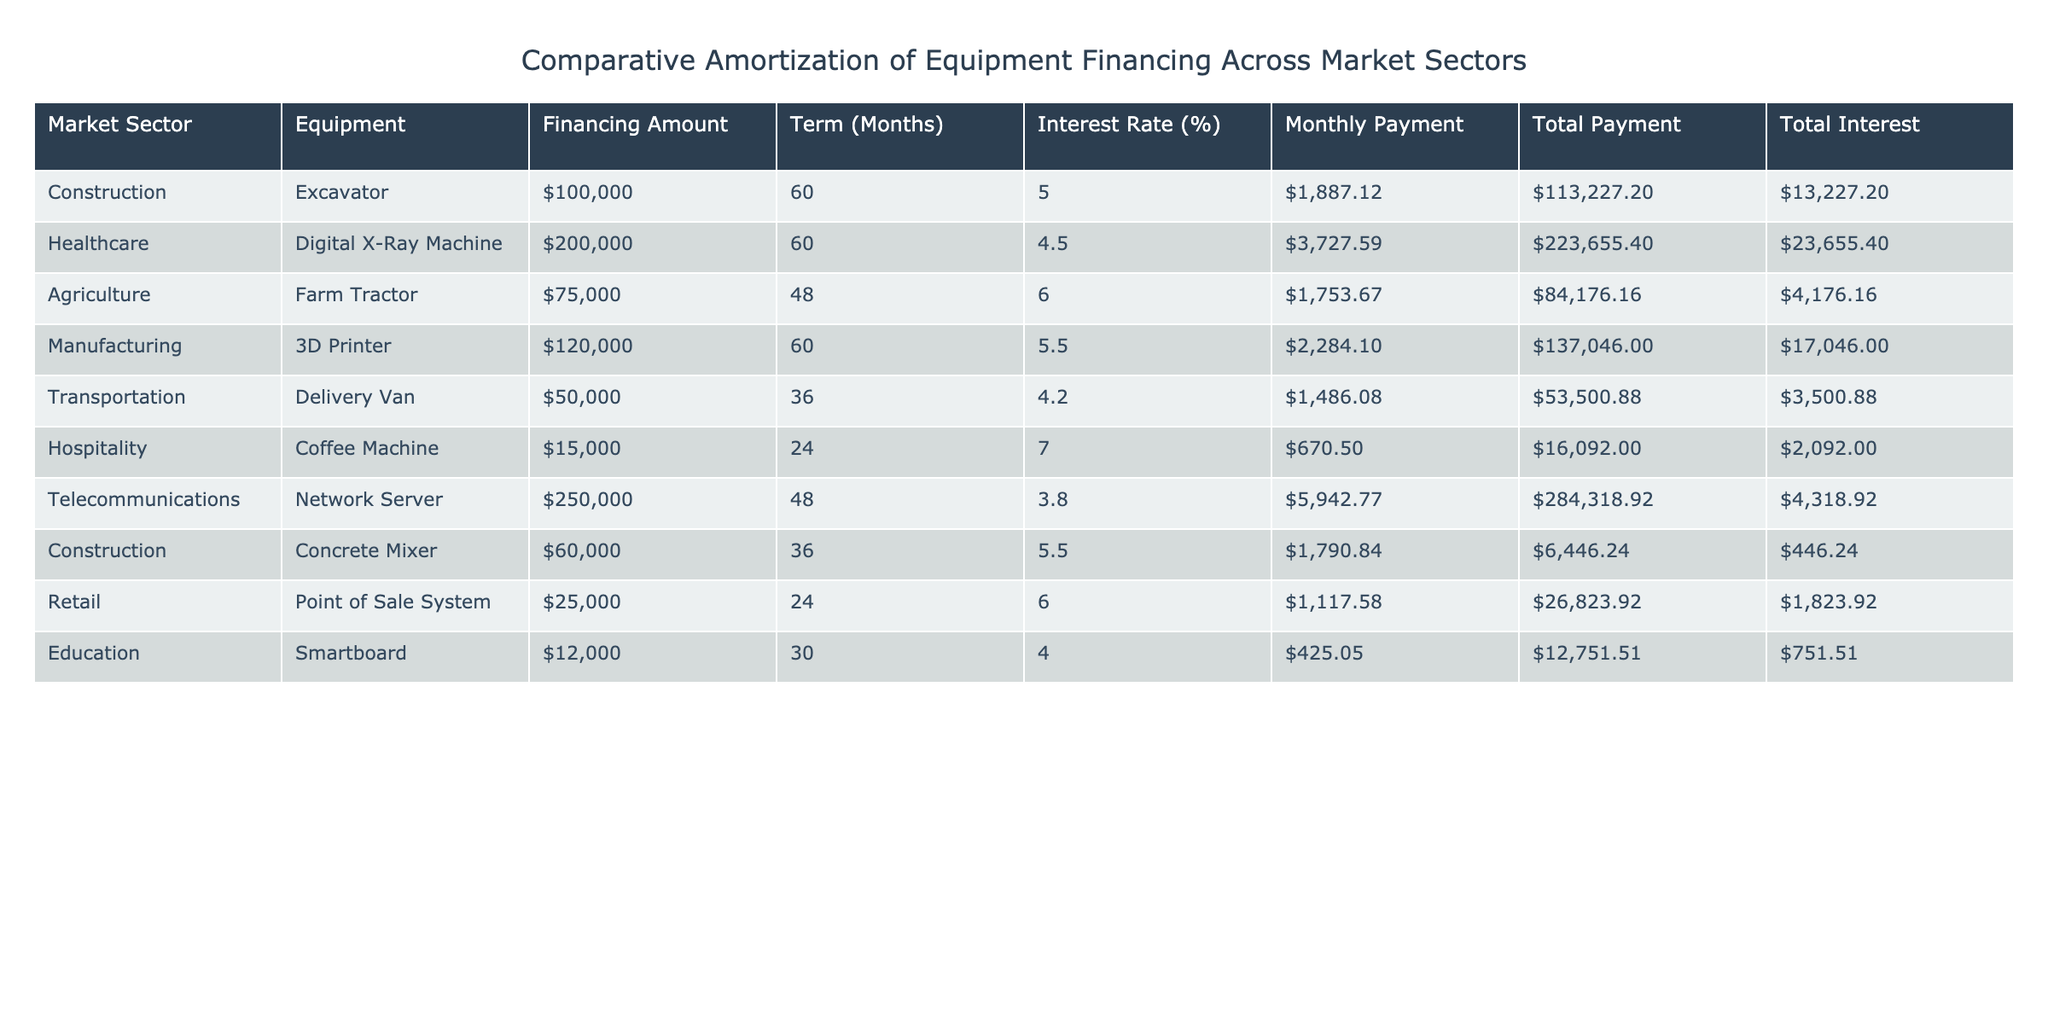What is the financing amount for the healthcare sector? The healthcare sector has a Digital X-Ray Machine with a financing amount of $200,000 listed in the table.
Answer: $200,000 Which equipment has the highest total payment? The telecommunications sector features a Network Server with a total payment of $284,318.92, the highest in the table when compared to other total payments listed.
Answer: $284,318.92 What is the average monthly payment across all market sectors? First, we sum the monthly payments: (1887.12 + 3727.59 + 1753.67 + 2284.10 + 1486.08 + 670.50 + 5942.77 + 1790.84 + 1117.58 + 425.05) = 29,796.26. Then, we divide by the number of market sectors, which is 10, resulting in an average monthly payment of 29,796.26/10 = 2,979.63.
Answer: $2,979.63 Is the total interest for the excavator greater than the total interest for the coffee machine? The total interest for the excavator is $13,227.20 and for the coffee machine it is $2,092.00. Since 13,227.20 is greater than 2,092.00, the statement is true.
Answer: Yes What is the difference in total payment between the agriculture and manufacturing sectors? The agriculture sector has a total payment of $84,176.16 and the manufacturing sector has a total payment of $137,046.00. The difference is calculated as 137,046.00 - 84,176.16 = 52,869.84.
Answer: $52,869.84 Which sector has the lowest monthly payment, and how much is it? The hospitality sector has a Coffee Machine with the lowest monthly payment of $670.50, and this amount is less than any other sector's monthly payment listed.
Answer: $670.50 What is the total interest paid for all the equipment in the construction sector combined? The total interest for the excavator is $13,227.20 and the concrete mixer is $446.24. Adding these gives us a total interest for the construction sector of $13,227.20 + $446.24 = $13,673.44.
Answer: $13,673.44 Is the interest rate for the delivery van higher than 5%? The interest rate for the delivery van is 4.2%, which is less than 5%. Therefore, the statement is false.
Answer: No What is the monthly payment difference between the digital X-ray machine and the 3D printer? The digital X-ray machine's monthly payment is $3,727.59 and the 3D printer's monthly payment is $2,284.10. The difference is $3,727.59 - $2,284.10 = $1,443.49.
Answer: $1,443.49 